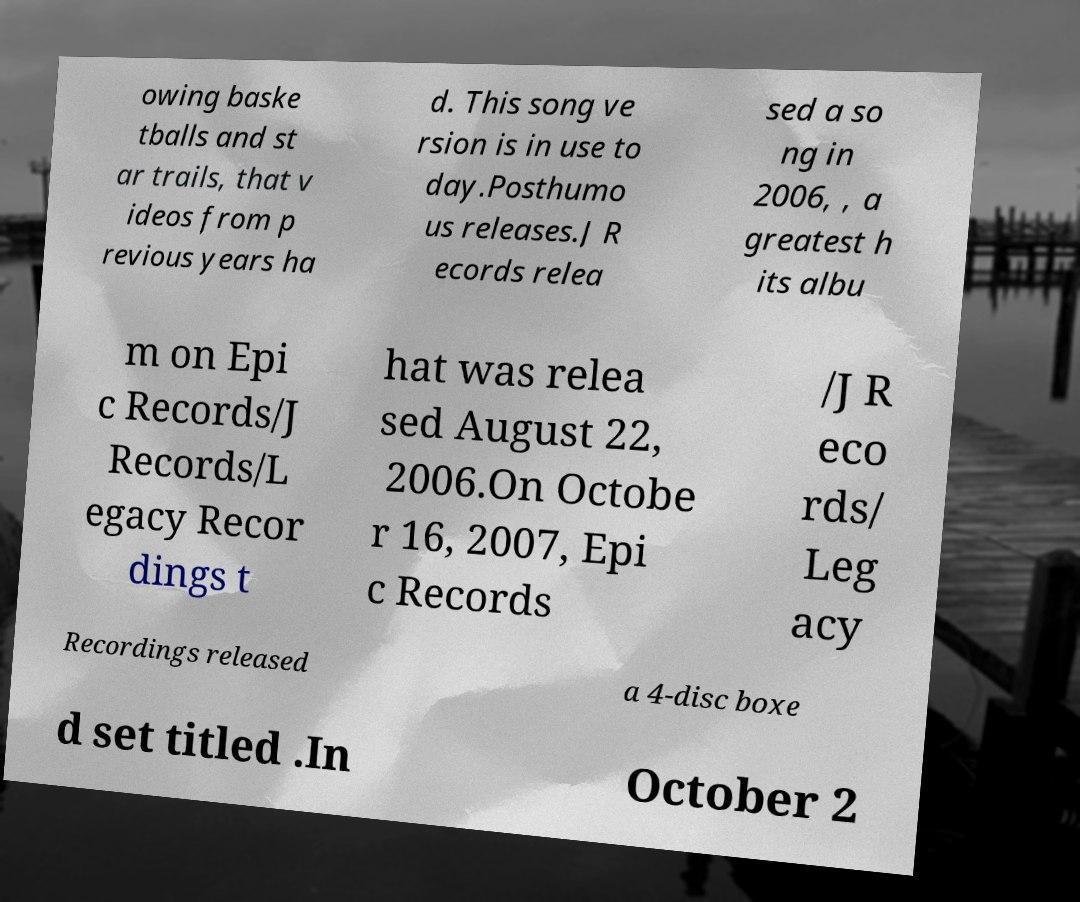Please identify and transcribe the text found in this image. owing baske tballs and st ar trails, that v ideos from p revious years ha d. This song ve rsion is in use to day.Posthumo us releases.J R ecords relea sed a so ng in 2006, , a greatest h its albu m on Epi c Records/J Records/L egacy Recor dings t hat was relea sed August 22, 2006.On Octobe r 16, 2007, Epi c Records /J R eco rds/ Leg acy Recordings released a 4-disc boxe d set titled .In October 2 